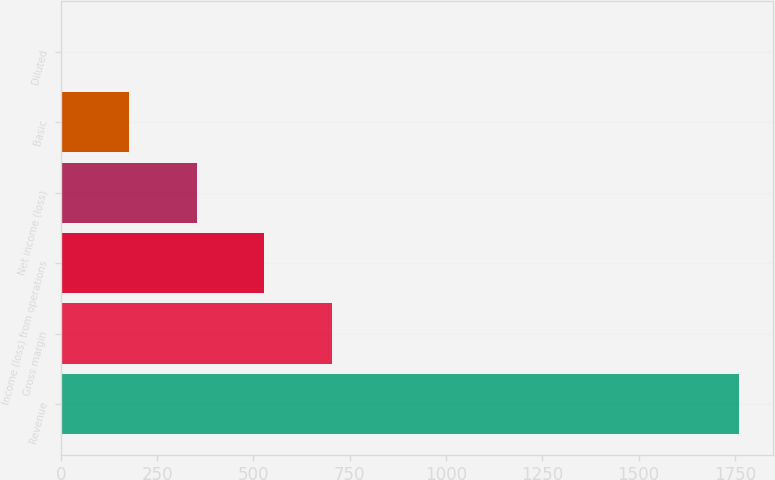Convert chart to OTSL. <chart><loc_0><loc_0><loc_500><loc_500><bar_chart><fcel>Revenue<fcel>Gross margin<fcel>Income (loss) from operations<fcel>Net income (loss)<fcel>Basic<fcel>Diluted<nl><fcel>1760<fcel>704.25<fcel>528.29<fcel>352.33<fcel>176.37<fcel>0.41<nl></chart> 